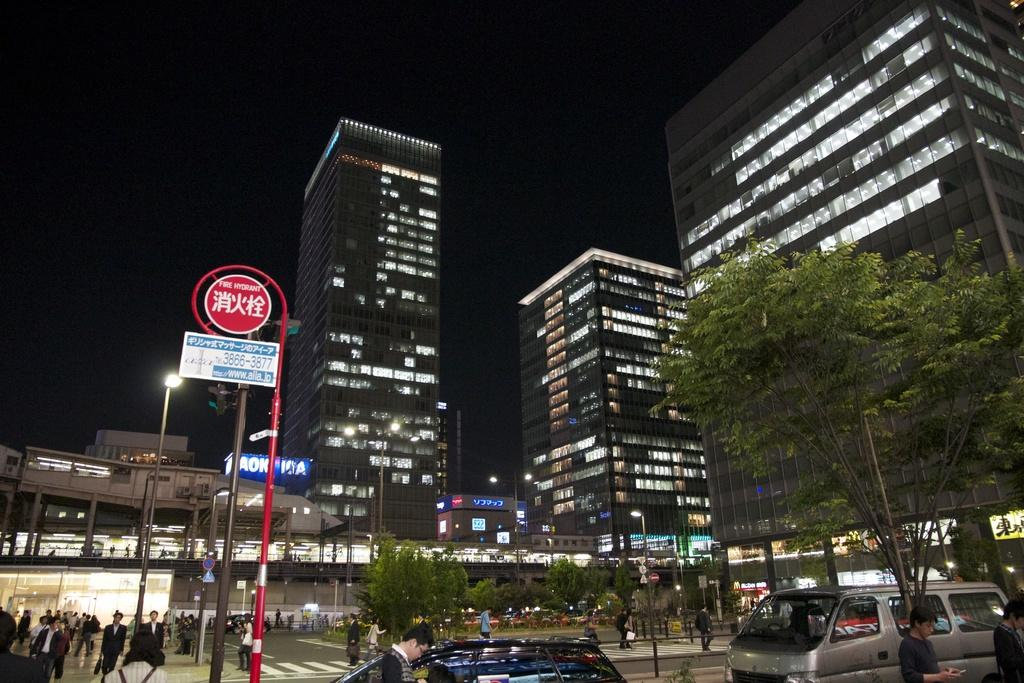What can be seen in the center of the image? There are buildings and trees in the center of the image. What is located at the bottom of the image? There are cars at the bottom of the image. Can you identify any living beings in the image? Yes, there are people visible in the image. What is on the left side of the image? There are boards on the left side of the image. What can be seen in the background of the image? The sky is visible in the background of the image. How many apples are hanging from the trees in the image? There is no mention of apples in the image; it features buildings, trees, cars, people, boards, and the sky. What historical event is being commemorated by the boards in the image? There is no indication of a historical event being commemorated by the boards in the image. 